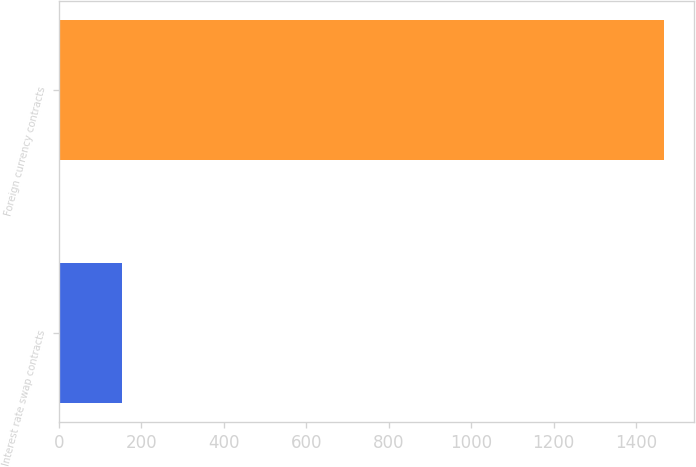<chart> <loc_0><loc_0><loc_500><loc_500><bar_chart><fcel>Interest rate swap contracts<fcel>Foreign currency contracts<nl><fcel>152.2<fcel>1468.4<nl></chart> 